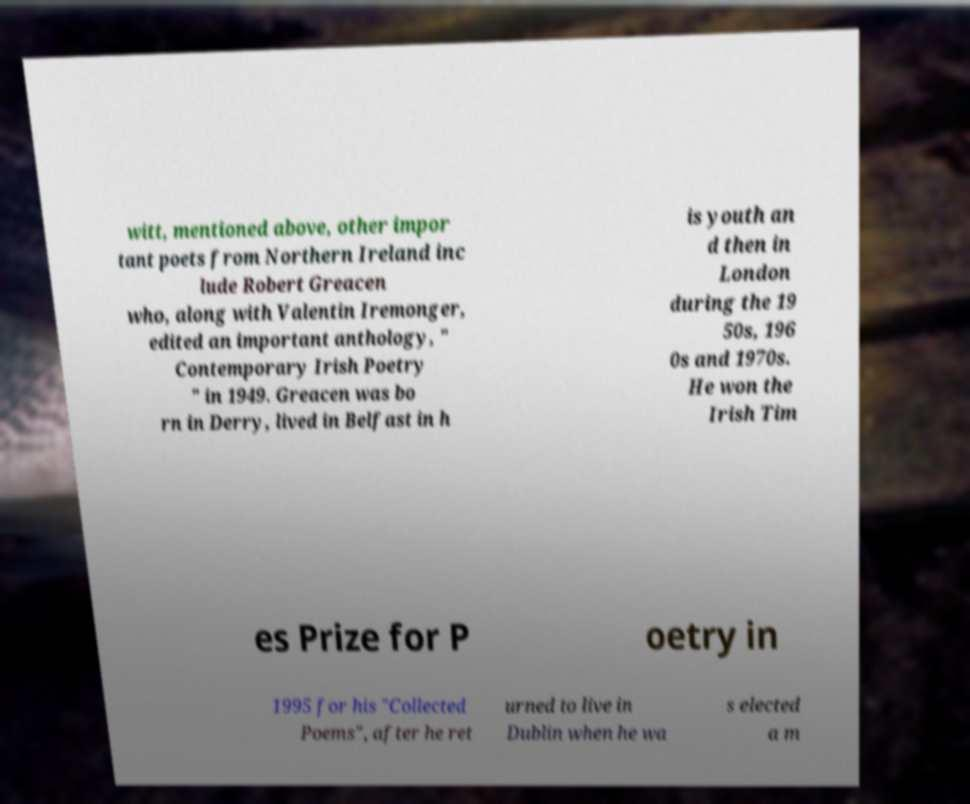Could you assist in decoding the text presented in this image and type it out clearly? witt, mentioned above, other impor tant poets from Northern Ireland inc lude Robert Greacen who, along with Valentin Iremonger, edited an important anthology, " Contemporary Irish Poetry " in 1949. Greacen was bo rn in Derry, lived in Belfast in h is youth an d then in London during the 19 50s, 196 0s and 1970s. He won the Irish Tim es Prize for P oetry in 1995 for his "Collected Poems", after he ret urned to live in Dublin when he wa s elected a m 